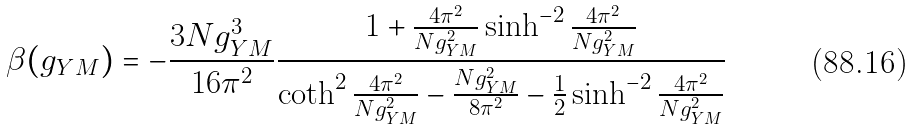<formula> <loc_0><loc_0><loc_500><loc_500>\beta ( g _ { Y M } ) = - \frac { 3 N g _ { Y M } ^ { 3 } } { 1 6 \pi ^ { 2 } } \frac { 1 + \frac { 4 \pi ^ { 2 } } { N g _ { Y M } ^ { 2 } } \sinh ^ { - 2 } \frac { 4 \pi ^ { 2 } } { N g _ { Y M } ^ { 2 } } } { \coth ^ { 2 } \frac { 4 \pi ^ { 2 } } { N g _ { Y M } ^ { 2 } } - \frac { N g ^ { 2 } _ { Y M } } { 8 \pi ^ { 2 } } - \frac { 1 } { 2 } \sinh ^ { - 2 } \frac { 4 \pi ^ { 2 } } { N g _ { Y M } ^ { 2 } } }</formula> 